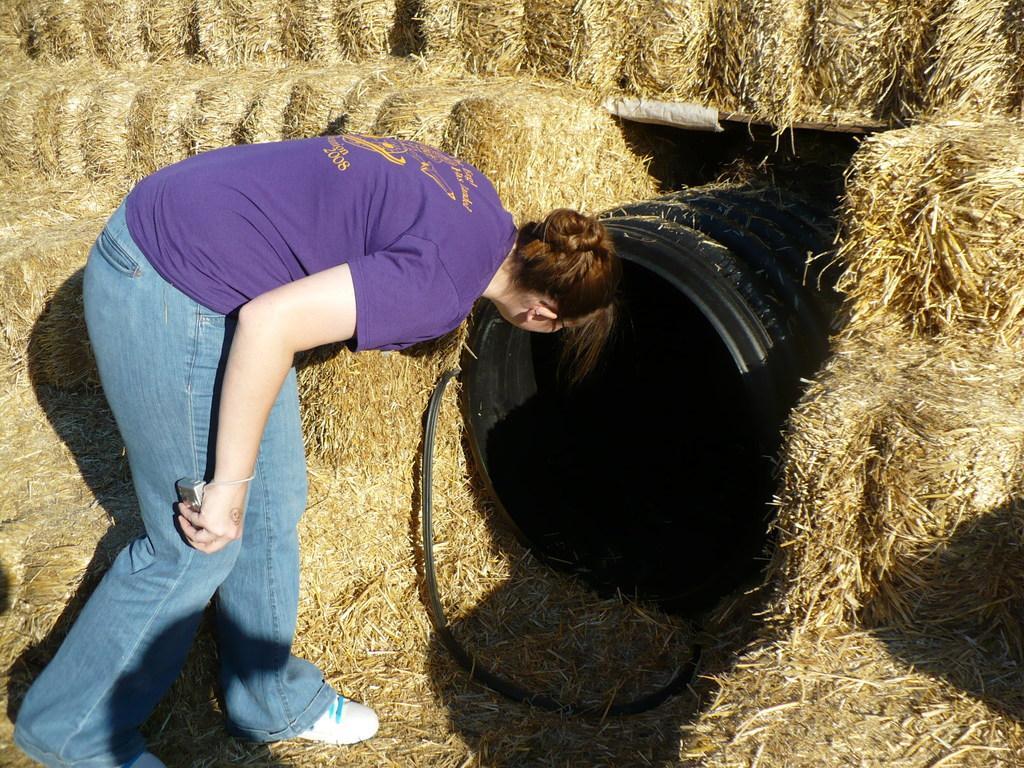How would you summarize this image in a sentence or two? In this image, we can see a woman looking in the black color object, we can see dried grass. 